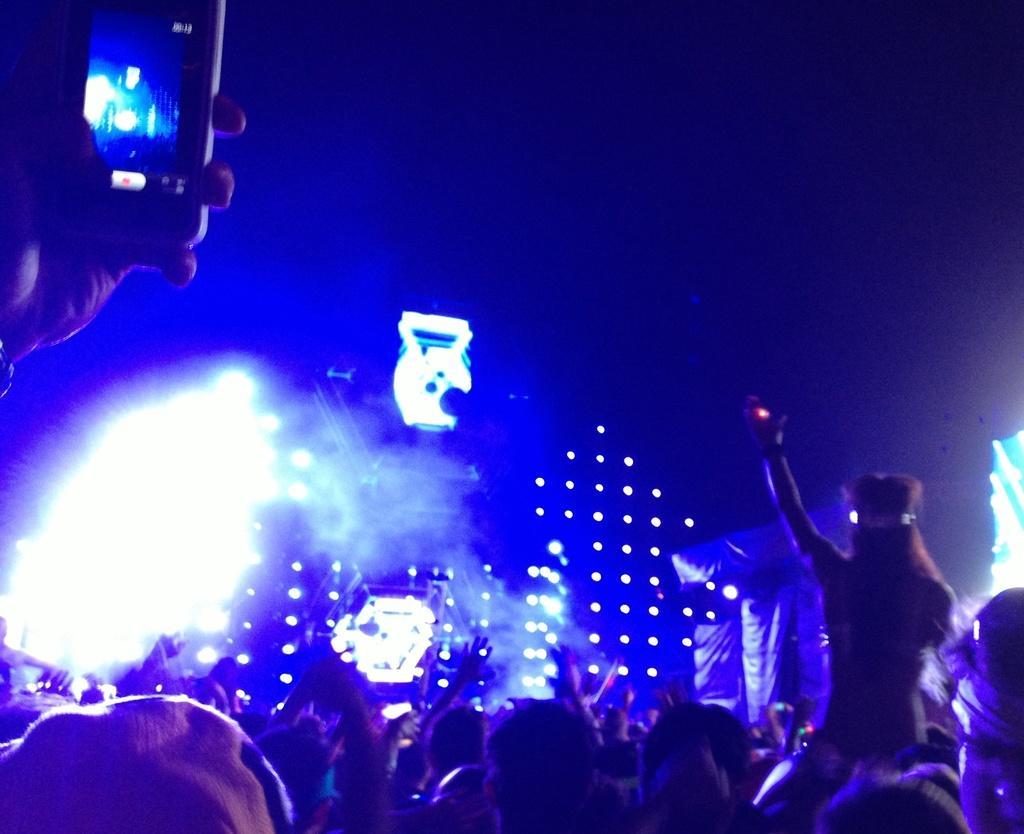Could you give a brief overview of what you see in this image? This image is taken in a concert. In the background there are a few lights. At the bottom of the image there are many people waving their hands. On the left side of the image a person is clicking pictures with a mobile phone. On the right side of the image there is another person holding a camera and clicking pictures. 